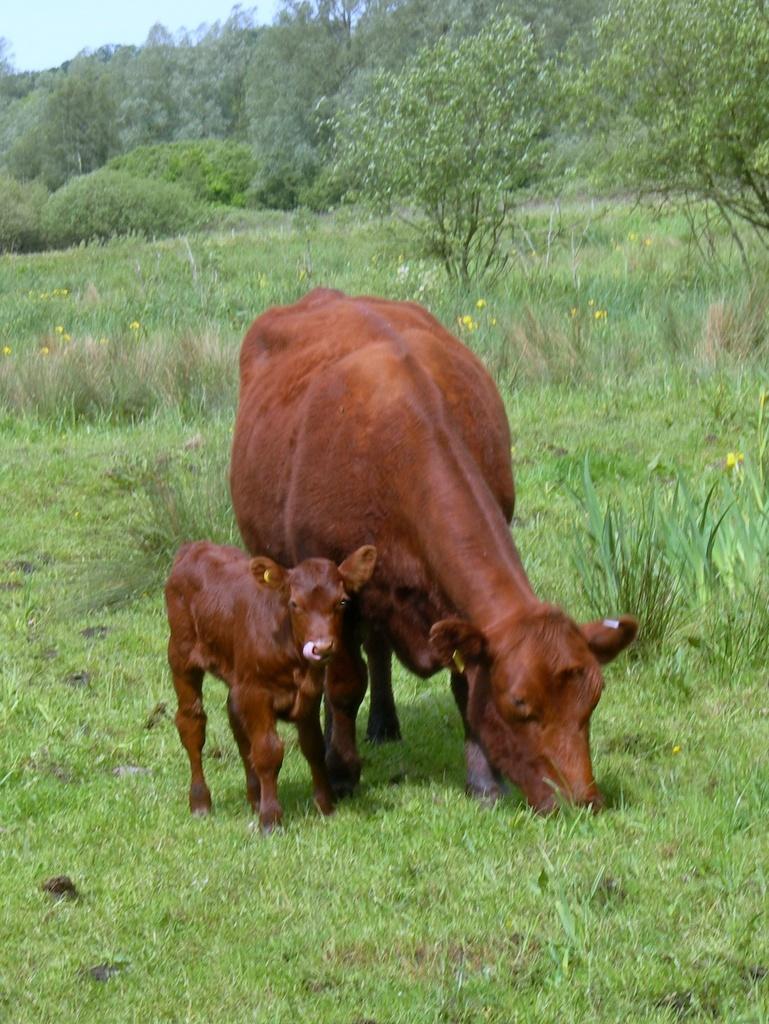Could you give a brief overview of what you see in this image? In this picture we can see brown cow eating a grass from the ground. Beside there is a baby cow and behind there are many trees. 